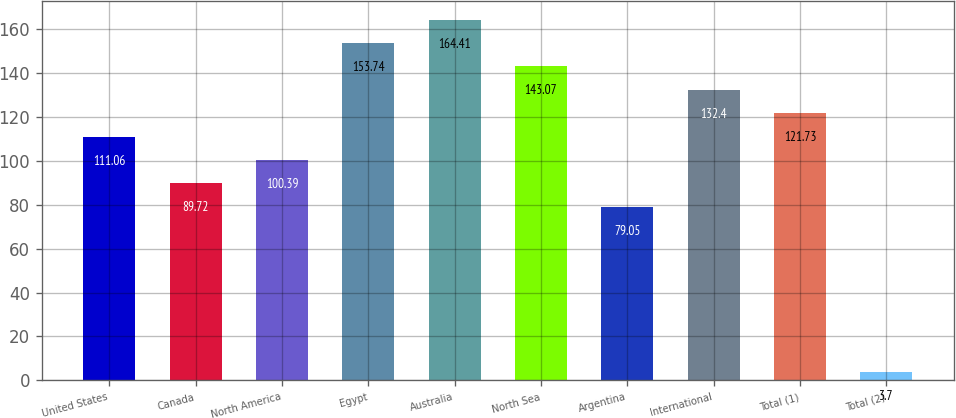Convert chart to OTSL. <chart><loc_0><loc_0><loc_500><loc_500><bar_chart><fcel>United States<fcel>Canada<fcel>North America<fcel>Egypt<fcel>Australia<fcel>North Sea<fcel>Argentina<fcel>International<fcel>Total (1)<fcel>Total (2)<nl><fcel>111.06<fcel>89.72<fcel>100.39<fcel>153.74<fcel>164.41<fcel>143.07<fcel>79.05<fcel>132.4<fcel>121.73<fcel>3.7<nl></chart> 